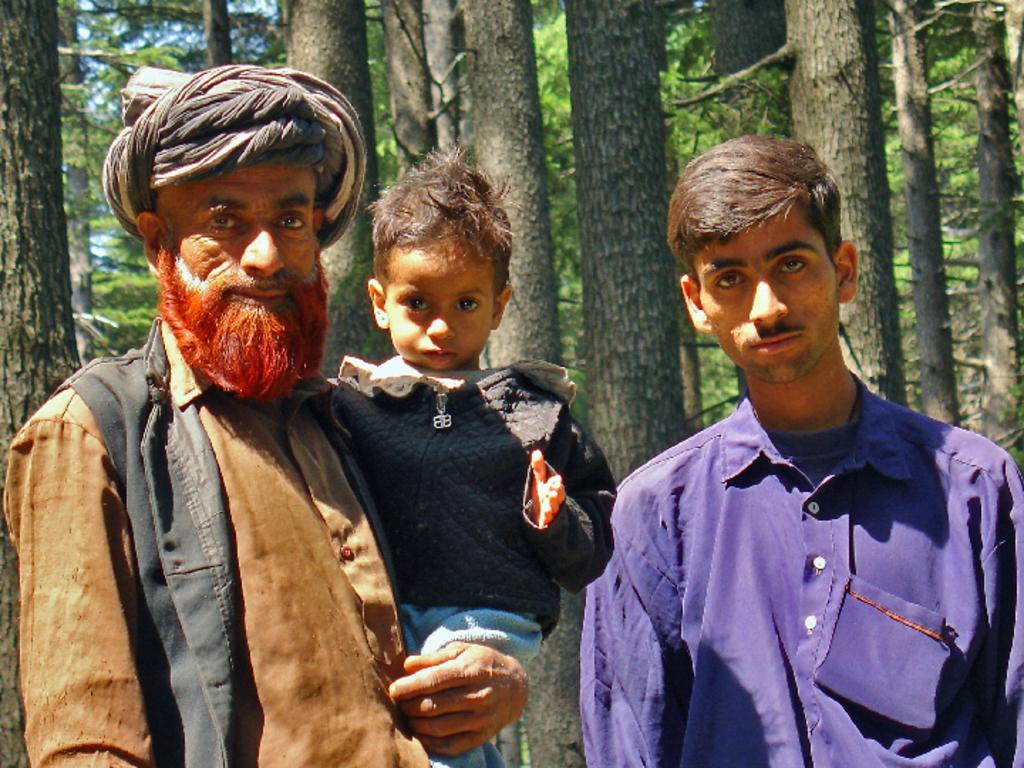How would you summarize this image in a sentence or two? In the picture I can see two men are standing among them the man on the left side is carrying a boy. In the background I can see trees. 